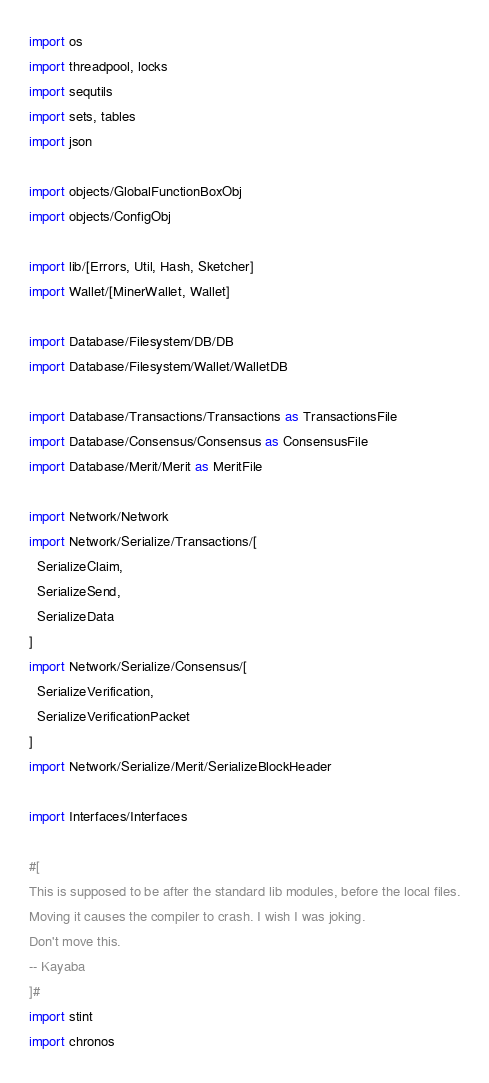Convert code to text. <code><loc_0><loc_0><loc_500><loc_500><_Nim_>import os
import threadpool, locks
import sequtils
import sets, tables
import json

import objects/GlobalFunctionBoxObj
import objects/ConfigObj

import lib/[Errors, Util, Hash, Sketcher]
import Wallet/[MinerWallet, Wallet]

import Database/Filesystem/DB/DB
import Database/Filesystem/Wallet/WalletDB

import Database/Transactions/Transactions as TransactionsFile
import Database/Consensus/Consensus as ConsensusFile
import Database/Merit/Merit as MeritFile

import Network/Network
import Network/Serialize/Transactions/[
  SerializeClaim,
  SerializeSend,
  SerializeData
]
import Network/Serialize/Consensus/[
  SerializeVerification,
  SerializeVerificationPacket
]
import Network/Serialize/Merit/SerializeBlockHeader

import Interfaces/Interfaces

#[
This is supposed to be after the standard lib modules, before the local files.
Moving it causes the compiler to crash. I wish I was joking.
Don't move this.
-- Kayaba
]#
import stint
import chronos
</code> 